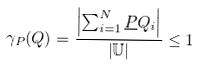Convert formula to latex. <formula><loc_0><loc_0><loc_500><loc_500>\gamma _ { P } ( Q ) = { \frac { \left | \sum _ { i = 1 } ^ { N } { \underline { P } } Q _ { i } \right | } { \left | \mathbb { U } \right | } } \leq 1</formula> 